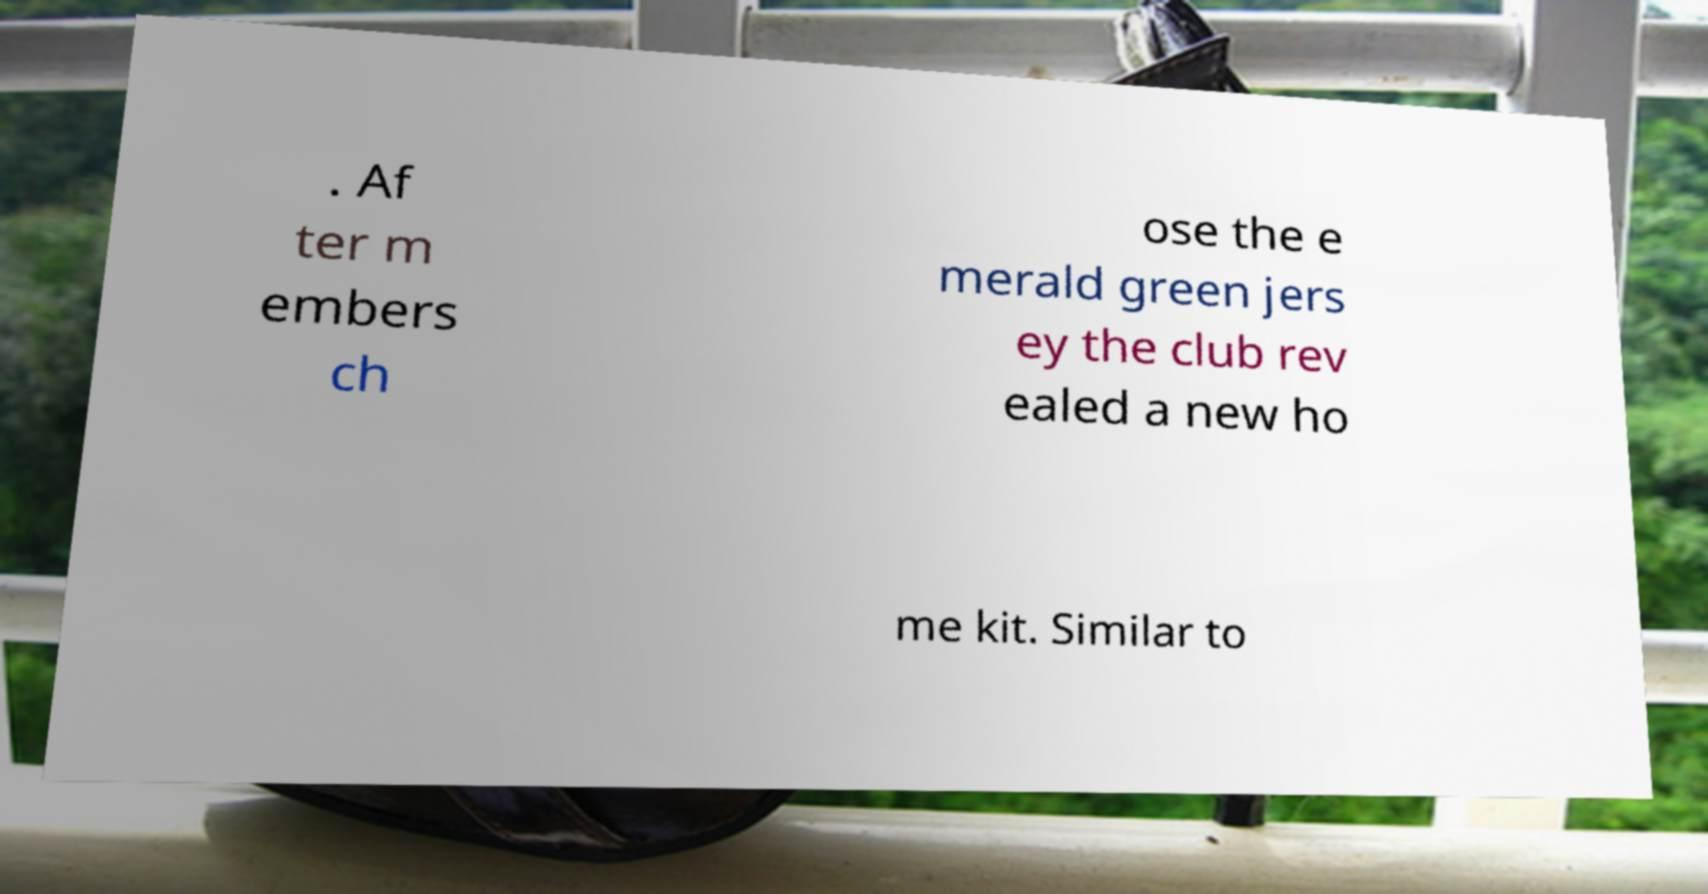Please identify and transcribe the text found in this image. . Af ter m embers ch ose the e merald green jers ey the club rev ealed a new ho me kit. Similar to 